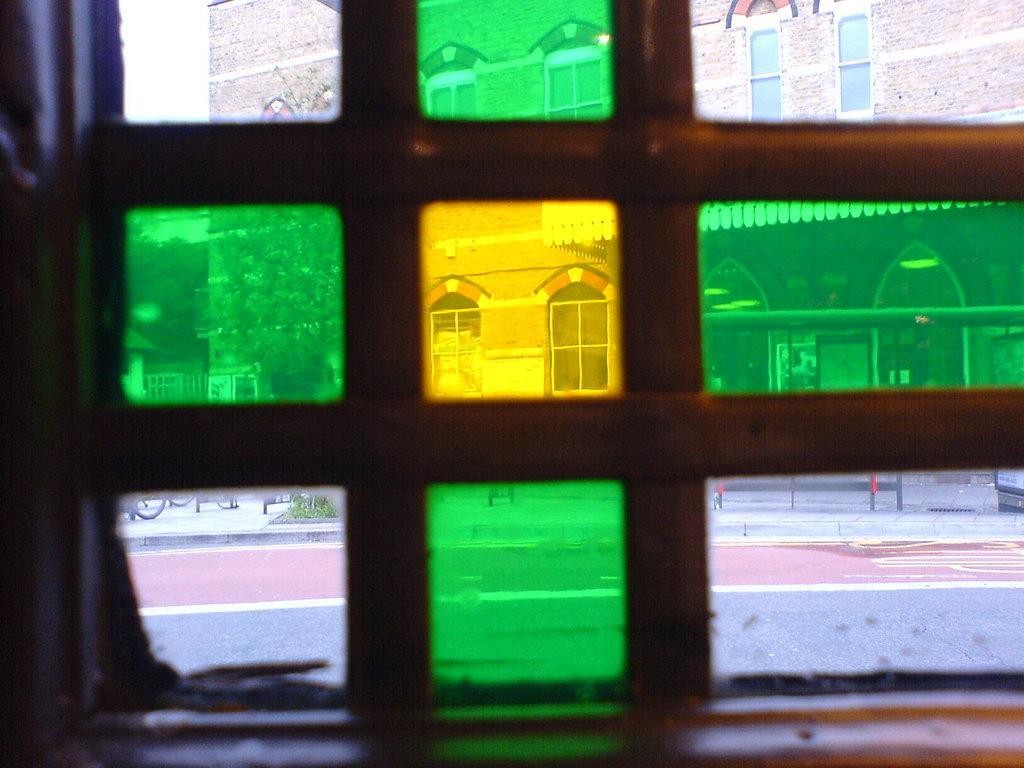Could you give a brief overview of what you see in this image? It seems like a window at the bottom of this image. We can see a building and trees through this window. 